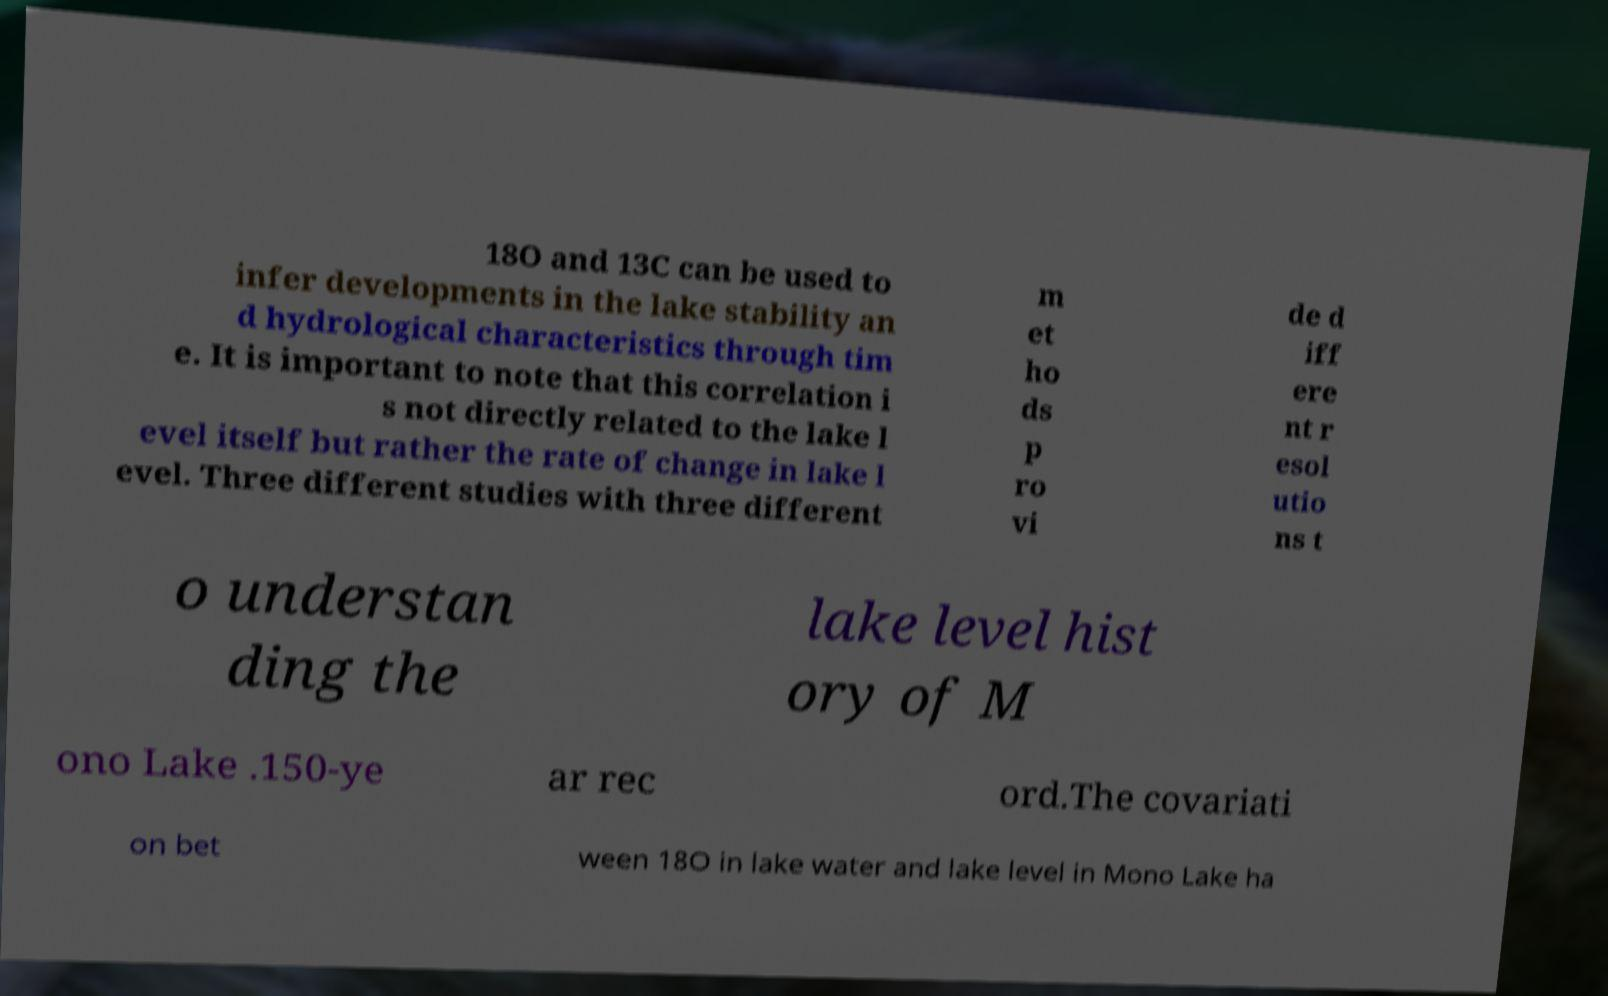Can you accurately transcribe the text from the provided image for me? 18O and 13C can be used to infer developments in the lake stability an d hydrological characteristics through tim e. It is important to note that this correlation i s not directly related to the lake l evel itself but rather the rate of change in lake l evel. Three different studies with three different m et ho ds p ro vi de d iff ere nt r esol utio ns t o understan ding the lake level hist ory of M ono Lake .150-ye ar rec ord.The covariati on bet ween 18O in lake water and lake level in Mono Lake ha 